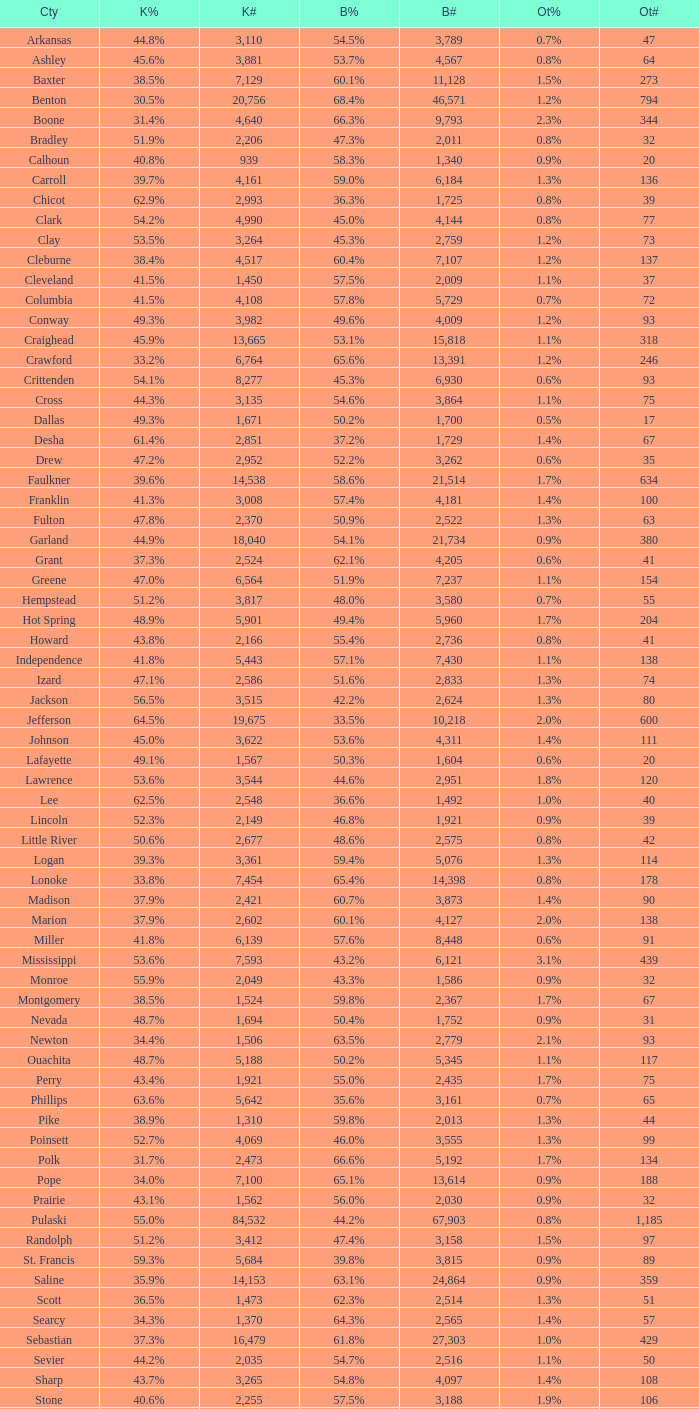What is the lowest Kerry#, when Others# is "106", and when Bush# is less than 3,188? None. 